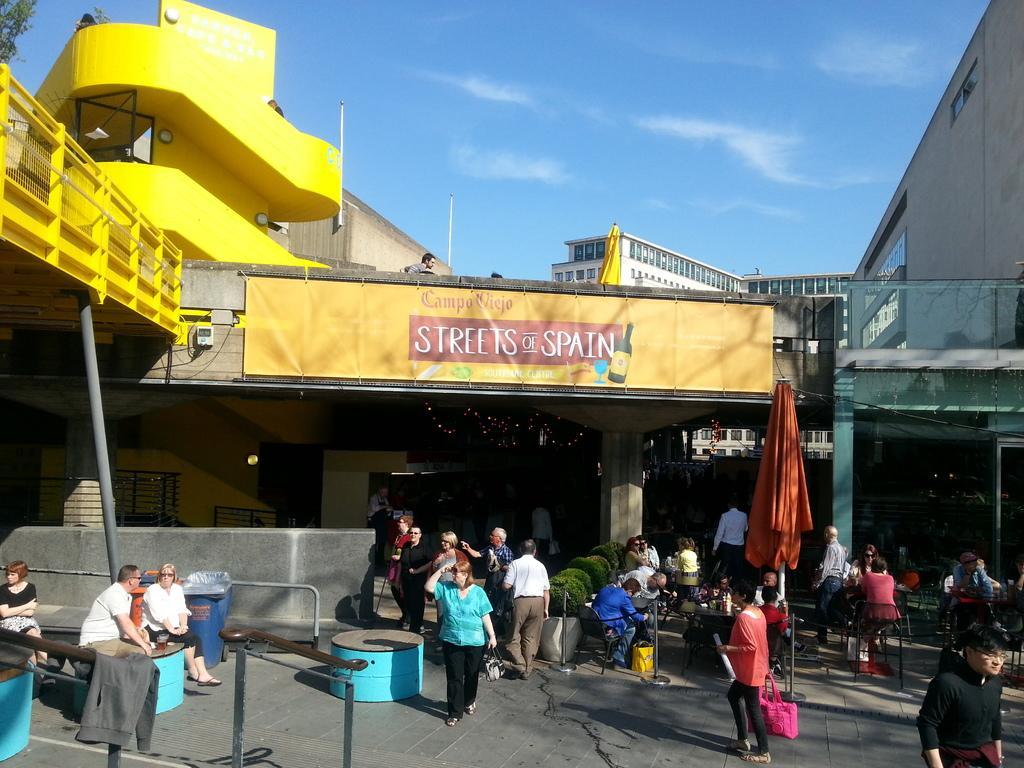Can you describe this image briefly? This picture is clicked outside the city. In this picture, we see people are standing and some of them are sitting. We see the blue color tables. At the bottom, we see the railing. In the middle of the picture, we see the people are sitting on the chairs. In front of them, we see a table on which many objects are placed. Behind that, we see a pole and a cloth in orange color. In the background, we see the buildings. We see a banner in yellow color with some text written on it. Beside that, we see a yellow color flag. On the left side, we see a tree and a building in yellow color. At the top, we see the sky. 